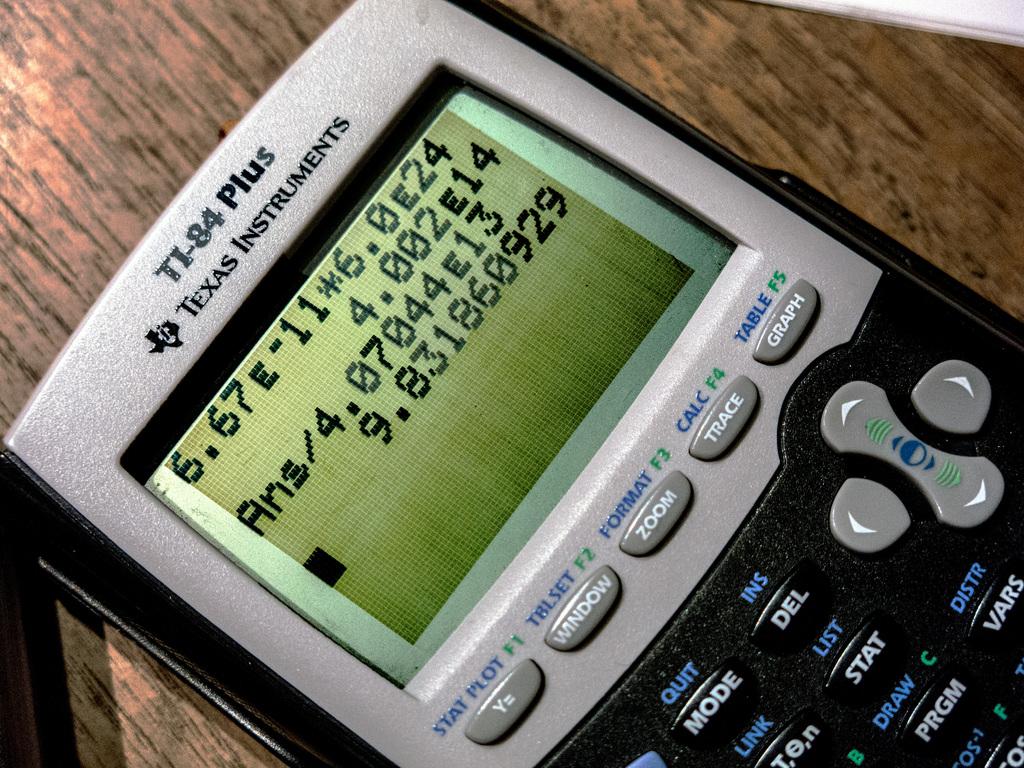Was this made by texas instruments?
Provide a succinct answer. Yes. What is the calculator number above texas instruments?
Keep it short and to the point. Ti-84. 